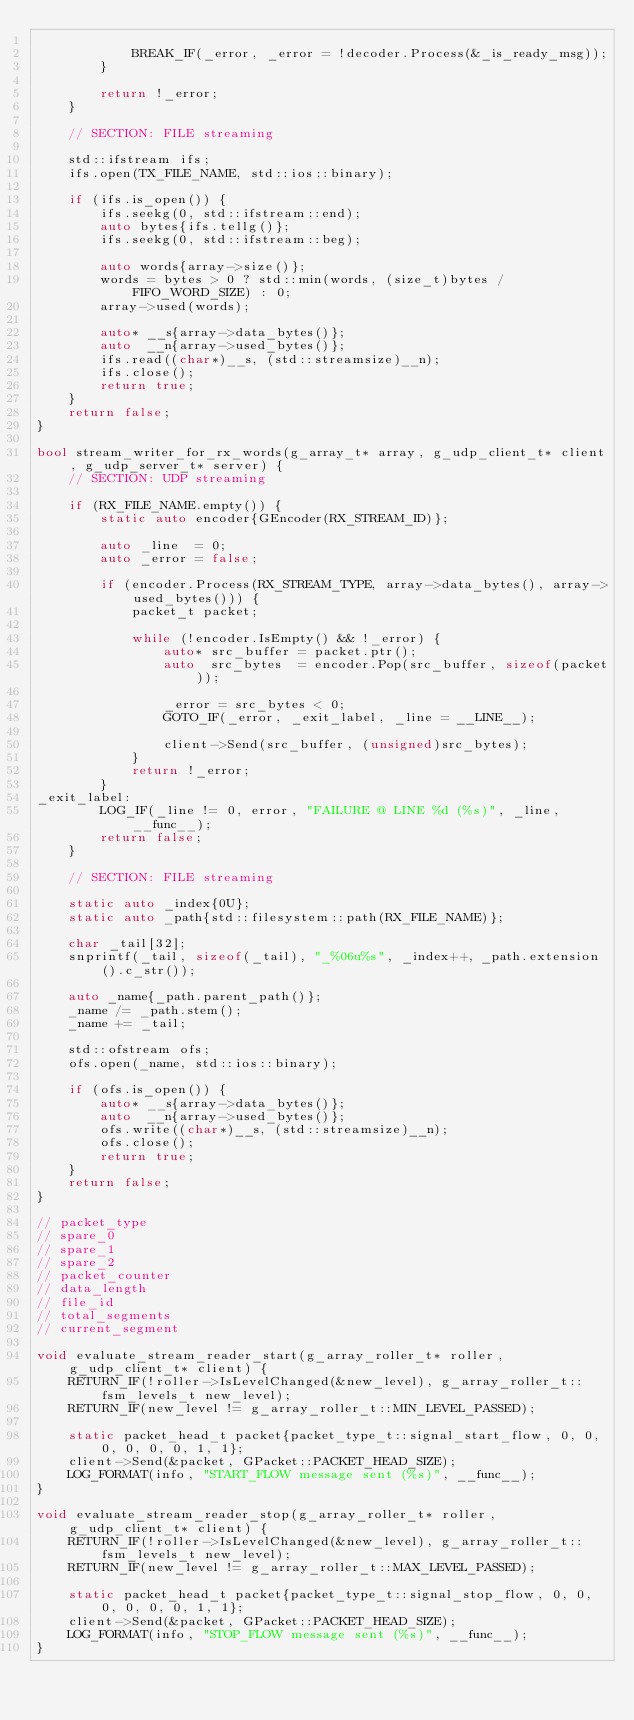Convert code to text. <code><loc_0><loc_0><loc_500><loc_500><_C++_>
            BREAK_IF(_error, _error = !decoder.Process(&_is_ready_msg));
        }

        return !_error;
    }

    // SECTION: FILE streaming

    std::ifstream ifs;
    ifs.open(TX_FILE_NAME, std::ios::binary);

    if (ifs.is_open()) {
        ifs.seekg(0, std::ifstream::end);
        auto bytes{ifs.tellg()};
        ifs.seekg(0, std::ifstream::beg);

        auto words{array->size()};
        words = bytes > 0 ? std::min(words, (size_t)bytes / FIFO_WORD_SIZE) : 0;
        array->used(words);

        auto* __s{array->data_bytes()};
        auto  __n{array->used_bytes()};
        ifs.read((char*)__s, (std::streamsize)__n);
        ifs.close();
        return true;
    }
    return false;
}

bool stream_writer_for_rx_words(g_array_t* array, g_udp_client_t* client, g_udp_server_t* server) {
    // SECTION: UDP streaming

    if (RX_FILE_NAME.empty()) {
        static auto encoder{GEncoder(RX_STREAM_ID)};

        auto _line  = 0;
        auto _error = false;

        if (encoder.Process(RX_STREAM_TYPE, array->data_bytes(), array->used_bytes())) {
            packet_t packet;

            while (!encoder.IsEmpty() && !_error) {
                auto* src_buffer = packet.ptr();
                auto  src_bytes  = encoder.Pop(src_buffer, sizeof(packet));

                _error = src_bytes < 0;
                GOTO_IF(_error, _exit_label, _line = __LINE__);

                client->Send(src_buffer, (unsigned)src_bytes);
            }
            return !_error;
        }
_exit_label:
        LOG_IF(_line != 0, error, "FAILURE @ LINE %d (%s)", _line, __func__);
        return false;
    }

    // SECTION: FILE streaming

    static auto _index{0U};
    static auto _path{std::filesystem::path(RX_FILE_NAME)};

    char _tail[32];
    snprintf(_tail, sizeof(_tail), "_%06u%s", _index++, _path.extension().c_str());

    auto _name{_path.parent_path()};
    _name /= _path.stem();
    _name += _tail;

    std::ofstream ofs;
    ofs.open(_name, std::ios::binary);

    if (ofs.is_open()) {
        auto* __s{array->data_bytes()};
        auto  __n{array->used_bytes()};
        ofs.write((char*)__s, (std::streamsize)__n);
        ofs.close();
        return true;
    }
    return false;
}

// packet_type
// spare_0
// spare_1
// spare_2
// packet_counter
// data_length
// file_id
// total_segments
// current_segment

void evaluate_stream_reader_start(g_array_roller_t* roller, g_udp_client_t* client) {
    RETURN_IF(!roller->IsLevelChanged(&new_level), g_array_roller_t::fsm_levels_t new_level);
    RETURN_IF(new_level != g_array_roller_t::MIN_LEVEL_PASSED);

    static packet_head_t packet{packet_type_t::signal_start_flow, 0, 0, 0, 0, 0, 0, 1, 1};
    client->Send(&packet, GPacket::PACKET_HEAD_SIZE);
    LOG_FORMAT(info, "START_FLOW message sent (%s)", __func__);
}

void evaluate_stream_reader_stop(g_array_roller_t* roller, g_udp_client_t* client) {
    RETURN_IF(!roller->IsLevelChanged(&new_level), g_array_roller_t::fsm_levels_t new_level);
    RETURN_IF(new_level != g_array_roller_t::MAX_LEVEL_PASSED);

    static packet_head_t packet{packet_type_t::signal_stop_flow, 0, 0, 0, 0, 0, 0, 1, 1};
    client->Send(&packet, GPacket::PACKET_HEAD_SIZE);
    LOG_FORMAT(info, "STOP_FLOW message sent (%s)", __func__);
}</code> 